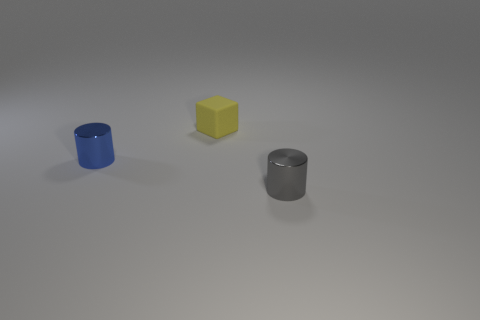How would you describe the lighting and mood in this scene? The lighting in the scene is soft and diffused, suggesting a calm and tranquil mood. It feels like an overcast day, where shadows are soft and faint.  What do the objects in this image appear to be? There are three objects: a cobalt blue cylindrical container, a yellow matte block, and a metallic grey cylindrical shape that looks like a canister. They seem like minimalistic representations of everyday items. 